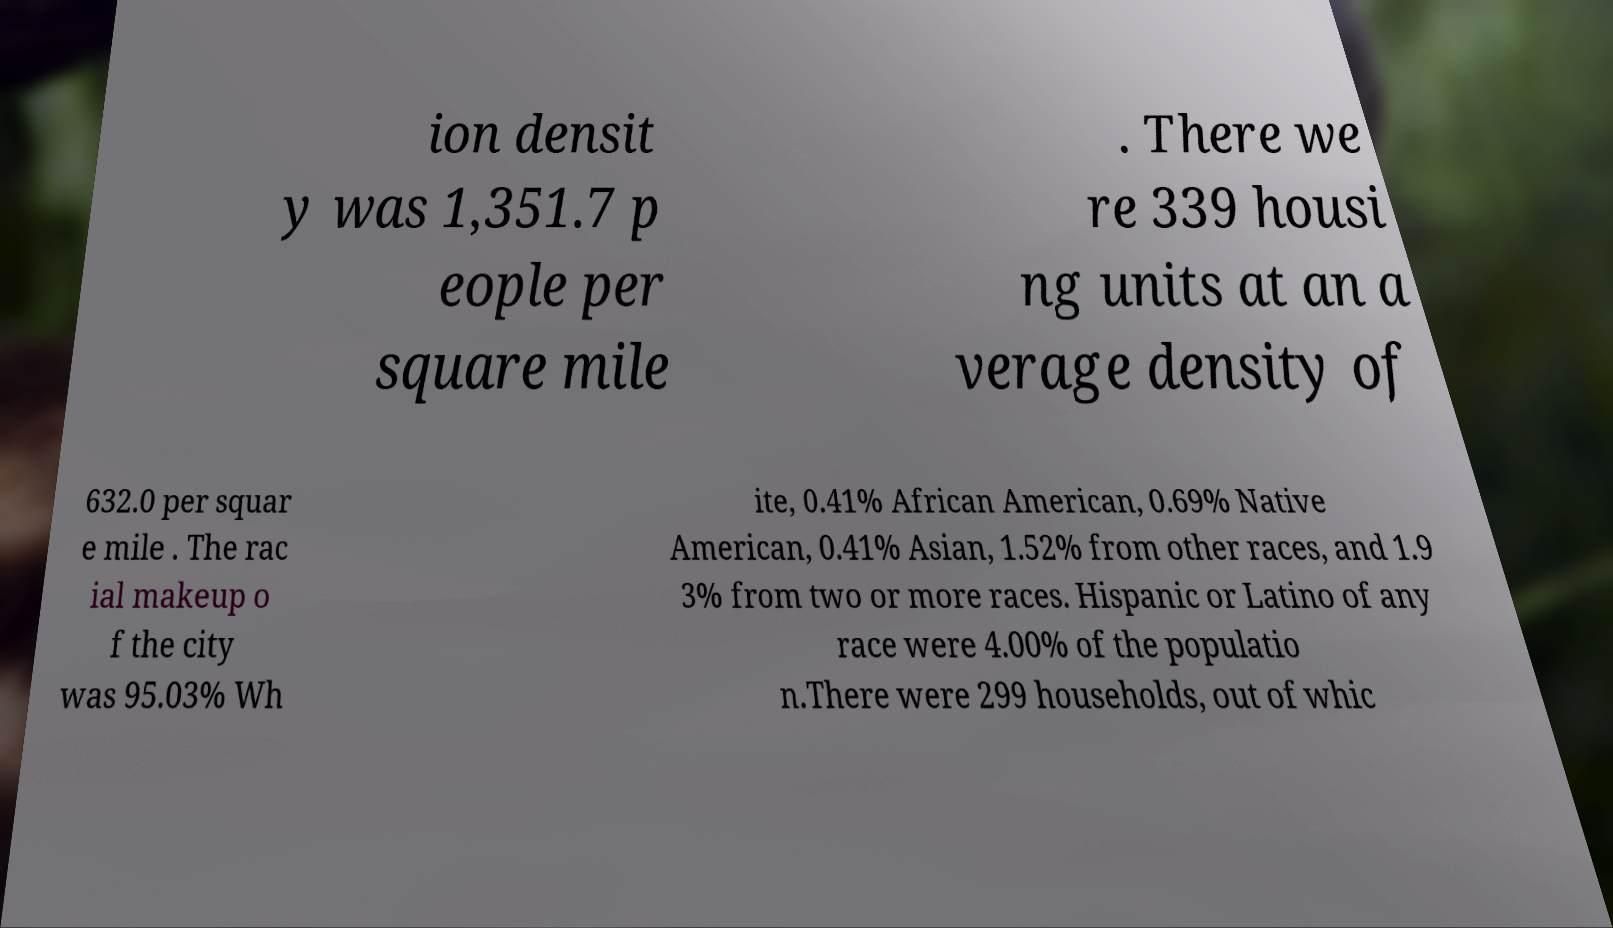Could you extract and type out the text from this image? ion densit y was 1,351.7 p eople per square mile . There we re 339 housi ng units at an a verage density of 632.0 per squar e mile . The rac ial makeup o f the city was 95.03% Wh ite, 0.41% African American, 0.69% Native American, 0.41% Asian, 1.52% from other races, and 1.9 3% from two or more races. Hispanic or Latino of any race were 4.00% of the populatio n.There were 299 households, out of whic 